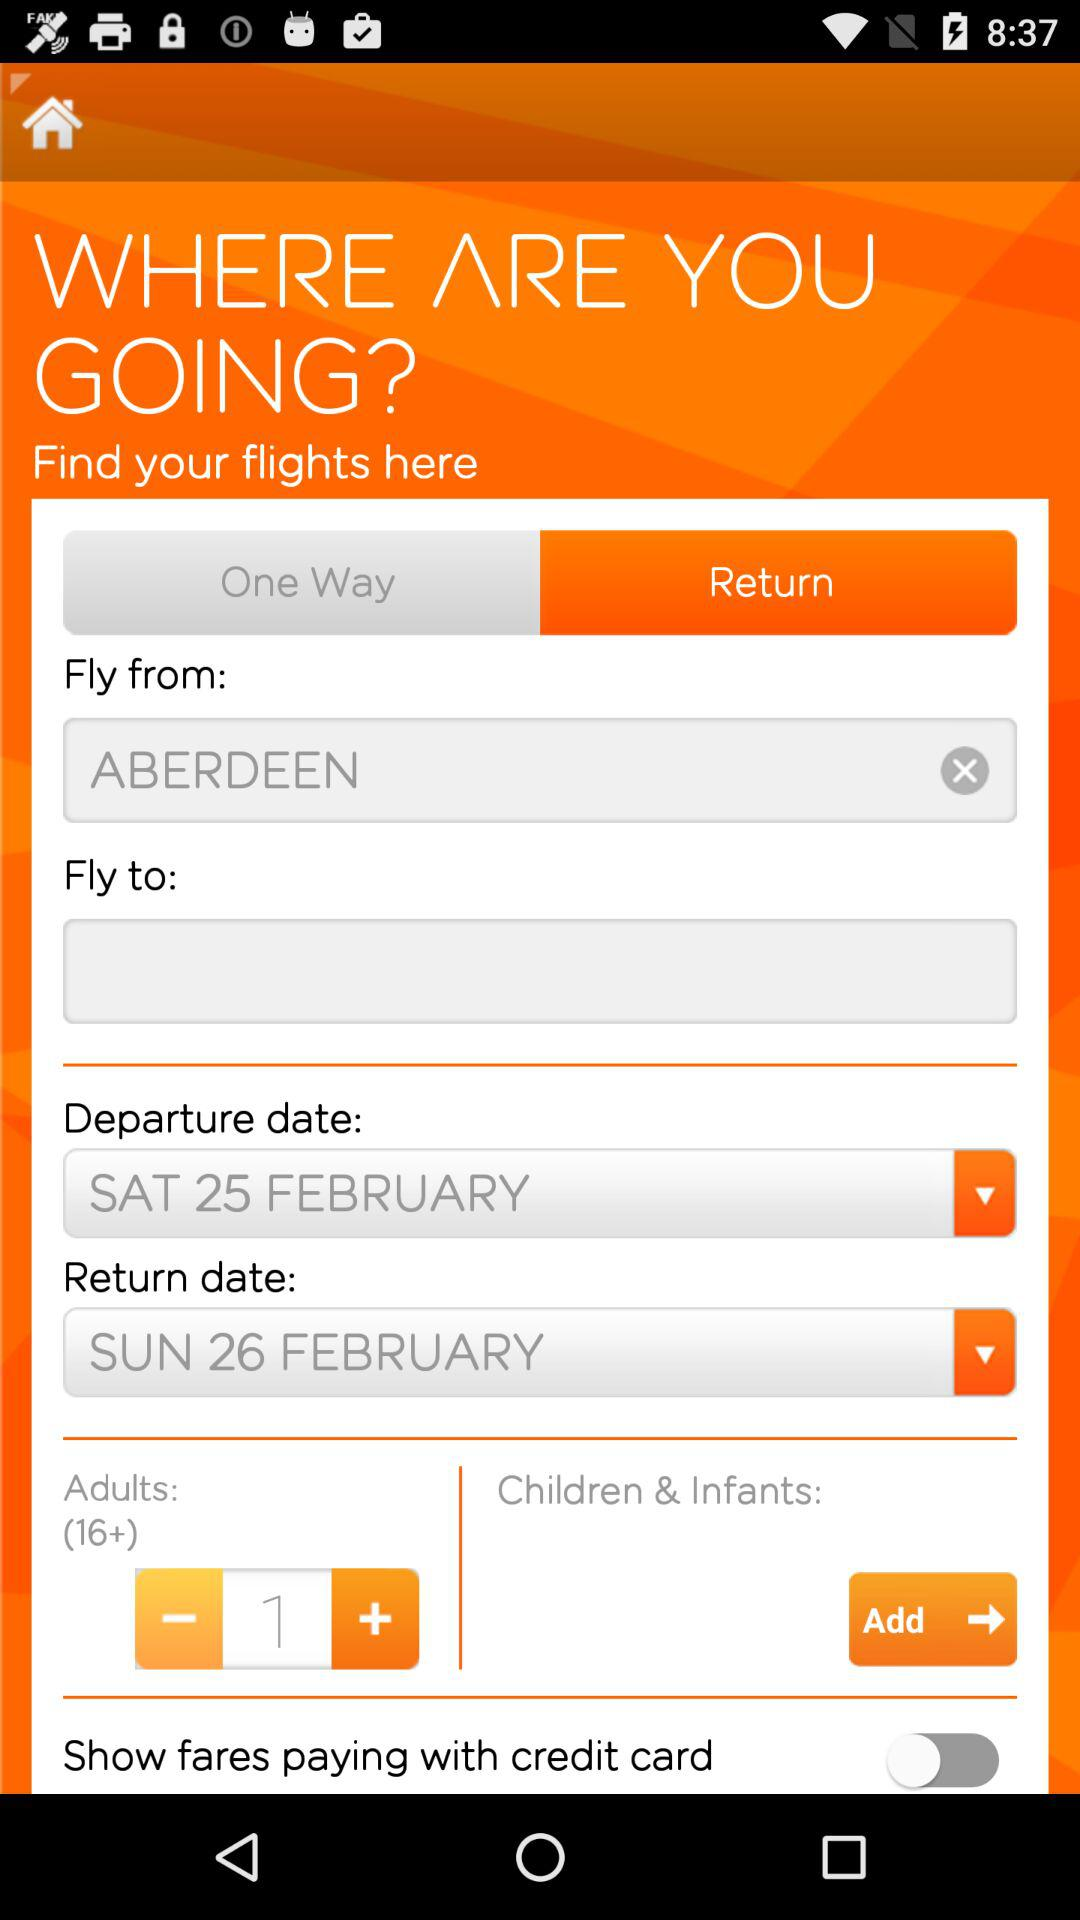What's the departure date? The departure date is Saturday, February 25. 